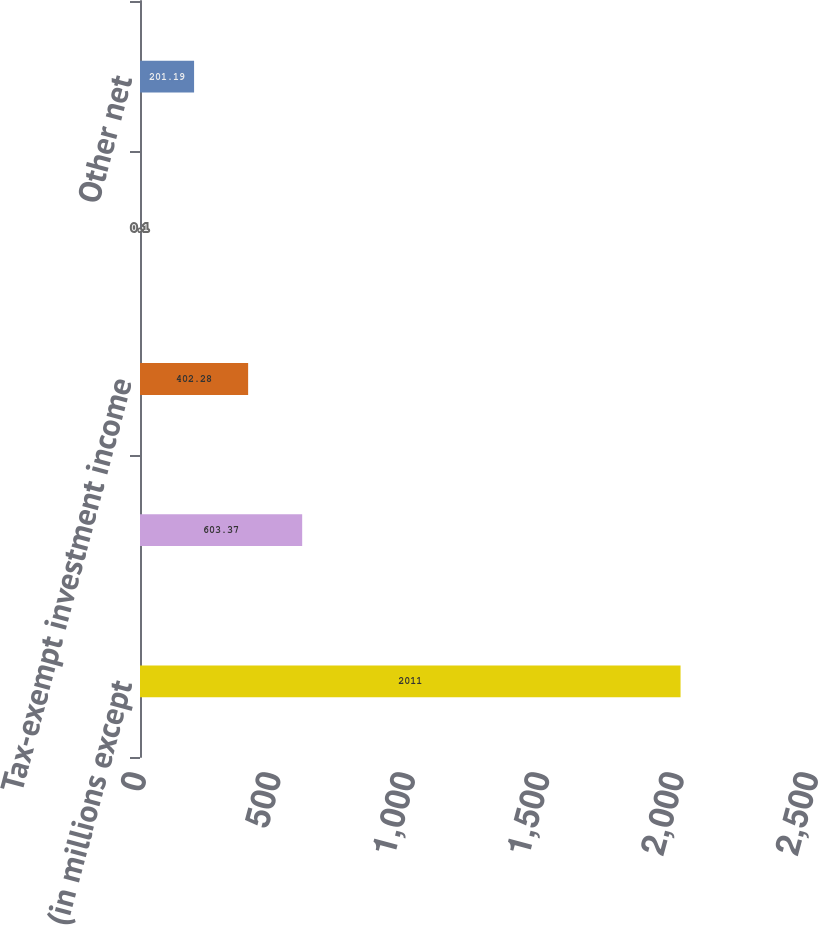<chart> <loc_0><loc_0><loc_500><loc_500><bar_chart><fcel>(in millions except<fcel>State income taxes net of<fcel>Tax-exempt investment income<fcel>Non-deductible compensation<fcel>Other net<nl><fcel>2011<fcel>603.37<fcel>402.28<fcel>0.1<fcel>201.19<nl></chart> 